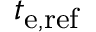Convert formula to latex. <formula><loc_0><loc_0><loc_500><loc_500>t _ { e , r e f }</formula> 